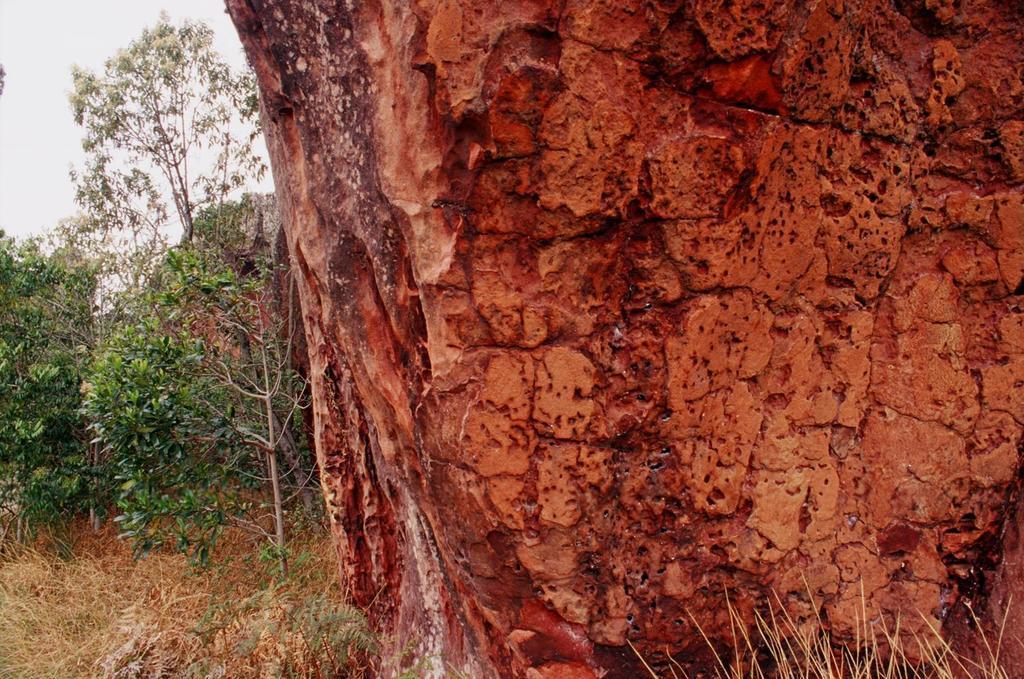Could you give a brief overview of what you see in this image? In this picture I can see there is a rock on to right and there are few trees in the backdrop and the sky is clear. 